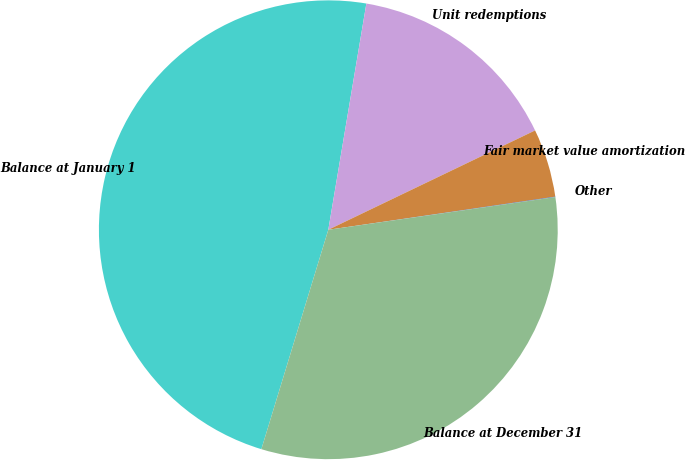<chart> <loc_0><loc_0><loc_500><loc_500><pie_chart><fcel>Balance at January 1<fcel>Unit redemptions<fcel>Fair market value amortization<fcel>Other<fcel>Balance at December 31<nl><fcel>47.94%<fcel>15.22%<fcel>4.82%<fcel>0.03%<fcel>31.99%<nl></chart> 